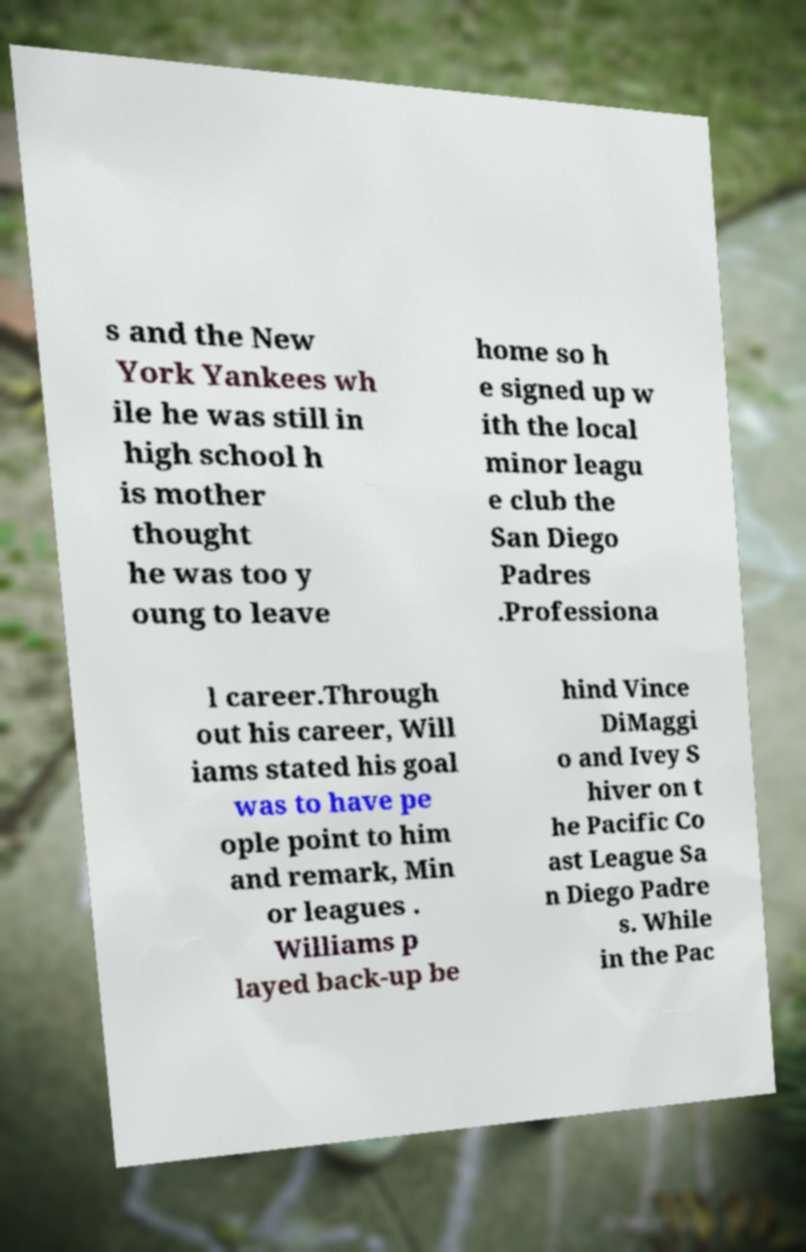Can you accurately transcribe the text from the provided image for me? s and the New York Yankees wh ile he was still in high school h is mother thought he was too y oung to leave home so h e signed up w ith the local minor leagu e club the San Diego Padres .Professiona l career.Through out his career, Will iams stated his goal was to have pe ople point to him and remark, Min or leagues . Williams p layed back-up be hind Vince DiMaggi o and Ivey S hiver on t he Pacific Co ast League Sa n Diego Padre s. While in the Pac 